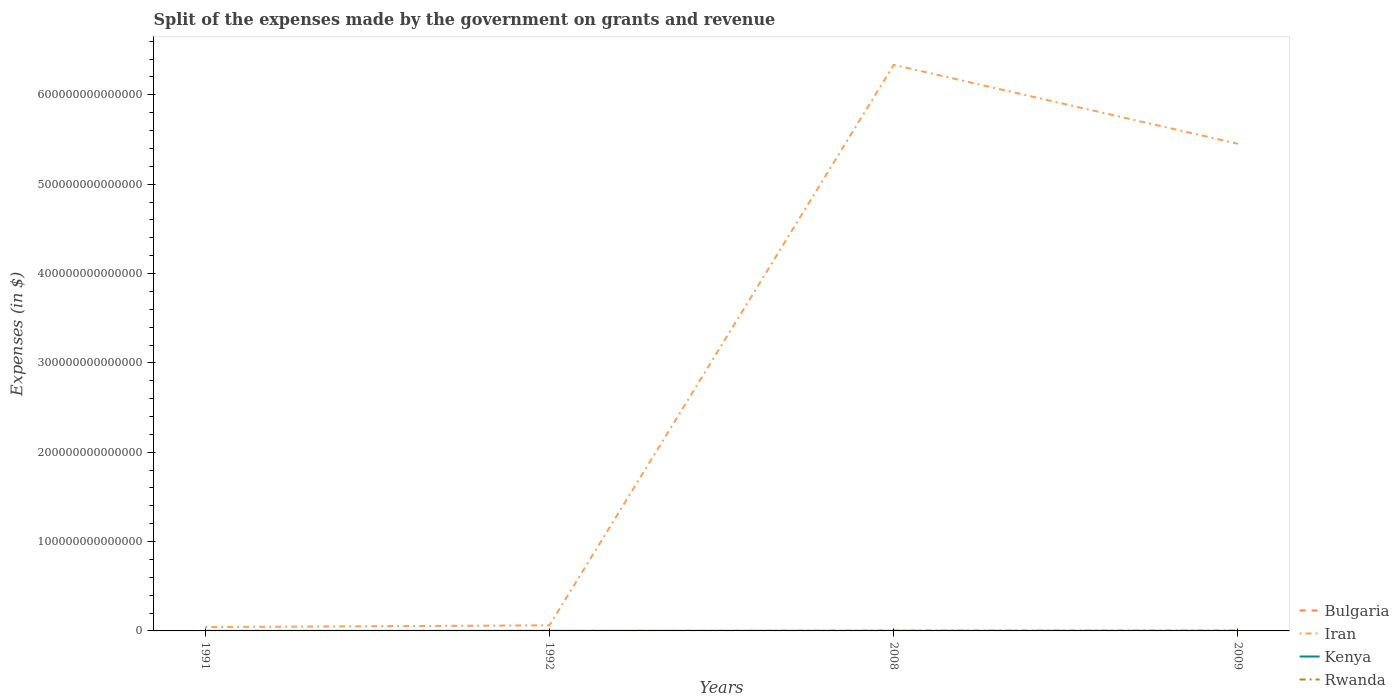Does the line corresponding to Kenya intersect with the line corresponding to Bulgaria?
Give a very brief answer. No. Is the number of lines equal to the number of legend labels?
Your response must be concise. Yes. Across all years, what is the maximum expenses made by the government on grants and revenue in Bulgaria?
Offer a very short reply. 7.79e+06. In which year was the expenses made by the government on grants and revenue in Kenya maximum?
Provide a succinct answer. 1991. What is the total expenses made by the government on grants and revenue in Bulgaria in the graph?
Provide a short and direct response. -3.49e+09. What is the difference between the highest and the second highest expenses made by the government on grants and revenue in Bulgaria?
Offer a very short reply. 3.65e+09. Is the expenses made by the government on grants and revenue in Rwanda strictly greater than the expenses made by the government on grants and revenue in Bulgaria over the years?
Provide a short and direct response. No. What is the difference between two consecutive major ticks on the Y-axis?
Make the answer very short. 1.00e+14. Are the values on the major ticks of Y-axis written in scientific E-notation?
Give a very brief answer. No. Does the graph contain any zero values?
Your answer should be compact. No. How are the legend labels stacked?
Ensure brevity in your answer.  Vertical. What is the title of the graph?
Keep it short and to the point. Split of the expenses made by the government on grants and revenue. What is the label or title of the Y-axis?
Your answer should be very brief. Expenses (in $). What is the Expenses (in $) of Bulgaria in 1991?
Your answer should be very brief. 7.79e+06. What is the Expenses (in $) of Iran in 1991?
Offer a very short reply. 4.29e+12. What is the Expenses (in $) in Kenya in 1991?
Keep it short and to the point. 7.99e+09. What is the Expenses (in $) in Rwanda in 1991?
Offer a terse response. 2.63e+09. What is the Expenses (in $) in Bulgaria in 1992?
Offer a very short reply. 1.65e+07. What is the Expenses (in $) of Iran in 1992?
Your response must be concise. 6.26e+12. What is the Expenses (in $) in Kenya in 1992?
Your response must be concise. 1.10e+1. What is the Expenses (in $) of Rwanda in 1992?
Give a very brief answer. 3.37e+09. What is the Expenses (in $) of Bulgaria in 2008?
Keep it short and to the point. 3.50e+09. What is the Expenses (in $) in Iran in 2008?
Provide a short and direct response. 6.34e+14. What is the Expenses (in $) of Kenya in 2008?
Your answer should be compact. 4.58e+1. What is the Expenses (in $) of Rwanda in 2008?
Provide a short and direct response. 2.97e+11. What is the Expenses (in $) of Bulgaria in 2009?
Offer a terse response. 3.66e+09. What is the Expenses (in $) in Iran in 2009?
Provide a short and direct response. 5.45e+14. What is the Expenses (in $) of Kenya in 2009?
Offer a very short reply. 3.98e+1. What is the Expenses (in $) of Rwanda in 2009?
Ensure brevity in your answer.  3.59e+11. Across all years, what is the maximum Expenses (in $) of Bulgaria?
Give a very brief answer. 3.66e+09. Across all years, what is the maximum Expenses (in $) in Iran?
Provide a short and direct response. 6.34e+14. Across all years, what is the maximum Expenses (in $) of Kenya?
Your response must be concise. 4.58e+1. Across all years, what is the maximum Expenses (in $) in Rwanda?
Give a very brief answer. 3.59e+11. Across all years, what is the minimum Expenses (in $) in Bulgaria?
Your answer should be very brief. 7.79e+06. Across all years, what is the minimum Expenses (in $) of Iran?
Give a very brief answer. 4.29e+12. Across all years, what is the minimum Expenses (in $) of Kenya?
Make the answer very short. 7.99e+09. Across all years, what is the minimum Expenses (in $) in Rwanda?
Give a very brief answer. 2.63e+09. What is the total Expenses (in $) in Bulgaria in the graph?
Your response must be concise. 7.19e+09. What is the total Expenses (in $) in Iran in the graph?
Your response must be concise. 1.19e+15. What is the total Expenses (in $) in Kenya in the graph?
Keep it short and to the point. 1.05e+11. What is the total Expenses (in $) in Rwanda in the graph?
Provide a short and direct response. 6.62e+11. What is the difference between the Expenses (in $) of Bulgaria in 1991 and that in 1992?
Ensure brevity in your answer.  -8.75e+06. What is the difference between the Expenses (in $) of Iran in 1991 and that in 1992?
Provide a short and direct response. -1.97e+12. What is the difference between the Expenses (in $) of Kenya in 1991 and that in 1992?
Offer a terse response. -2.97e+09. What is the difference between the Expenses (in $) of Rwanda in 1991 and that in 1992?
Your answer should be compact. -7.39e+08. What is the difference between the Expenses (in $) of Bulgaria in 1991 and that in 2008?
Ensure brevity in your answer.  -3.49e+09. What is the difference between the Expenses (in $) in Iran in 1991 and that in 2008?
Keep it short and to the point. -6.29e+14. What is the difference between the Expenses (in $) in Kenya in 1991 and that in 2008?
Offer a terse response. -3.78e+1. What is the difference between the Expenses (in $) of Rwanda in 1991 and that in 2008?
Your response must be concise. -2.94e+11. What is the difference between the Expenses (in $) in Bulgaria in 1991 and that in 2009?
Your answer should be compact. -3.65e+09. What is the difference between the Expenses (in $) in Iran in 1991 and that in 2009?
Offer a terse response. -5.41e+14. What is the difference between the Expenses (in $) in Kenya in 1991 and that in 2009?
Offer a terse response. -3.18e+1. What is the difference between the Expenses (in $) of Rwanda in 1991 and that in 2009?
Ensure brevity in your answer.  -3.57e+11. What is the difference between the Expenses (in $) in Bulgaria in 1992 and that in 2008?
Keep it short and to the point. -3.48e+09. What is the difference between the Expenses (in $) of Iran in 1992 and that in 2008?
Keep it short and to the point. -6.27e+14. What is the difference between the Expenses (in $) of Kenya in 1992 and that in 2008?
Offer a very short reply. -3.48e+1. What is the difference between the Expenses (in $) of Rwanda in 1992 and that in 2008?
Your answer should be very brief. -2.94e+11. What is the difference between the Expenses (in $) of Bulgaria in 1992 and that in 2009?
Offer a very short reply. -3.64e+09. What is the difference between the Expenses (in $) in Iran in 1992 and that in 2009?
Make the answer very short. -5.39e+14. What is the difference between the Expenses (in $) in Kenya in 1992 and that in 2009?
Ensure brevity in your answer.  -2.88e+1. What is the difference between the Expenses (in $) in Rwanda in 1992 and that in 2009?
Your answer should be compact. -3.56e+11. What is the difference between the Expenses (in $) in Bulgaria in 2008 and that in 2009?
Offer a terse response. -1.61e+08. What is the difference between the Expenses (in $) of Iran in 2008 and that in 2009?
Give a very brief answer. 8.83e+13. What is the difference between the Expenses (in $) of Kenya in 2008 and that in 2009?
Provide a short and direct response. 6.02e+09. What is the difference between the Expenses (in $) of Rwanda in 2008 and that in 2009?
Your answer should be very brief. -6.22e+1. What is the difference between the Expenses (in $) of Bulgaria in 1991 and the Expenses (in $) of Iran in 1992?
Your answer should be compact. -6.26e+12. What is the difference between the Expenses (in $) in Bulgaria in 1991 and the Expenses (in $) in Kenya in 1992?
Ensure brevity in your answer.  -1.10e+1. What is the difference between the Expenses (in $) in Bulgaria in 1991 and the Expenses (in $) in Rwanda in 1992?
Your answer should be compact. -3.36e+09. What is the difference between the Expenses (in $) in Iran in 1991 and the Expenses (in $) in Kenya in 1992?
Offer a terse response. 4.28e+12. What is the difference between the Expenses (in $) in Iran in 1991 and the Expenses (in $) in Rwanda in 1992?
Make the answer very short. 4.29e+12. What is the difference between the Expenses (in $) in Kenya in 1991 and the Expenses (in $) in Rwanda in 1992?
Your answer should be compact. 4.62e+09. What is the difference between the Expenses (in $) of Bulgaria in 1991 and the Expenses (in $) of Iran in 2008?
Offer a terse response. -6.34e+14. What is the difference between the Expenses (in $) of Bulgaria in 1991 and the Expenses (in $) of Kenya in 2008?
Your answer should be very brief. -4.58e+1. What is the difference between the Expenses (in $) in Bulgaria in 1991 and the Expenses (in $) in Rwanda in 2008?
Offer a terse response. -2.97e+11. What is the difference between the Expenses (in $) in Iran in 1991 and the Expenses (in $) in Kenya in 2008?
Provide a succinct answer. 4.24e+12. What is the difference between the Expenses (in $) of Iran in 1991 and the Expenses (in $) of Rwanda in 2008?
Provide a short and direct response. 3.99e+12. What is the difference between the Expenses (in $) of Kenya in 1991 and the Expenses (in $) of Rwanda in 2008?
Keep it short and to the point. -2.89e+11. What is the difference between the Expenses (in $) of Bulgaria in 1991 and the Expenses (in $) of Iran in 2009?
Your answer should be compact. -5.45e+14. What is the difference between the Expenses (in $) in Bulgaria in 1991 and the Expenses (in $) in Kenya in 2009?
Your response must be concise. -3.98e+1. What is the difference between the Expenses (in $) of Bulgaria in 1991 and the Expenses (in $) of Rwanda in 2009?
Ensure brevity in your answer.  -3.59e+11. What is the difference between the Expenses (in $) of Iran in 1991 and the Expenses (in $) of Kenya in 2009?
Your response must be concise. 4.25e+12. What is the difference between the Expenses (in $) in Iran in 1991 and the Expenses (in $) in Rwanda in 2009?
Offer a very short reply. 3.93e+12. What is the difference between the Expenses (in $) of Kenya in 1991 and the Expenses (in $) of Rwanda in 2009?
Offer a terse response. -3.51e+11. What is the difference between the Expenses (in $) in Bulgaria in 1992 and the Expenses (in $) in Iran in 2008?
Your answer should be very brief. -6.34e+14. What is the difference between the Expenses (in $) of Bulgaria in 1992 and the Expenses (in $) of Kenya in 2008?
Give a very brief answer. -4.58e+1. What is the difference between the Expenses (in $) of Bulgaria in 1992 and the Expenses (in $) of Rwanda in 2008?
Your answer should be very brief. -2.97e+11. What is the difference between the Expenses (in $) of Iran in 1992 and the Expenses (in $) of Kenya in 2008?
Ensure brevity in your answer.  6.22e+12. What is the difference between the Expenses (in $) of Iran in 1992 and the Expenses (in $) of Rwanda in 2008?
Offer a terse response. 5.97e+12. What is the difference between the Expenses (in $) of Kenya in 1992 and the Expenses (in $) of Rwanda in 2008?
Provide a short and direct response. -2.86e+11. What is the difference between the Expenses (in $) of Bulgaria in 1992 and the Expenses (in $) of Iran in 2009?
Provide a short and direct response. -5.45e+14. What is the difference between the Expenses (in $) in Bulgaria in 1992 and the Expenses (in $) in Kenya in 2009?
Your response must be concise. -3.98e+1. What is the difference between the Expenses (in $) of Bulgaria in 1992 and the Expenses (in $) of Rwanda in 2009?
Your answer should be compact. -3.59e+11. What is the difference between the Expenses (in $) of Iran in 1992 and the Expenses (in $) of Kenya in 2009?
Offer a very short reply. 6.22e+12. What is the difference between the Expenses (in $) in Iran in 1992 and the Expenses (in $) in Rwanda in 2009?
Ensure brevity in your answer.  5.90e+12. What is the difference between the Expenses (in $) of Kenya in 1992 and the Expenses (in $) of Rwanda in 2009?
Your answer should be compact. -3.48e+11. What is the difference between the Expenses (in $) of Bulgaria in 2008 and the Expenses (in $) of Iran in 2009?
Your answer should be compact. -5.45e+14. What is the difference between the Expenses (in $) of Bulgaria in 2008 and the Expenses (in $) of Kenya in 2009?
Your answer should be very brief. -3.63e+1. What is the difference between the Expenses (in $) in Bulgaria in 2008 and the Expenses (in $) in Rwanda in 2009?
Offer a very short reply. -3.56e+11. What is the difference between the Expenses (in $) in Iran in 2008 and the Expenses (in $) in Kenya in 2009?
Provide a succinct answer. 6.34e+14. What is the difference between the Expenses (in $) in Iran in 2008 and the Expenses (in $) in Rwanda in 2009?
Your response must be concise. 6.33e+14. What is the difference between the Expenses (in $) of Kenya in 2008 and the Expenses (in $) of Rwanda in 2009?
Your answer should be very brief. -3.13e+11. What is the average Expenses (in $) in Bulgaria per year?
Keep it short and to the point. 1.80e+09. What is the average Expenses (in $) of Iran per year?
Provide a succinct answer. 2.97e+14. What is the average Expenses (in $) of Kenya per year?
Your answer should be compact. 2.61e+1. What is the average Expenses (in $) in Rwanda per year?
Ensure brevity in your answer.  1.66e+11. In the year 1991, what is the difference between the Expenses (in $) in Bulgaria and Expenses (in $) in Iran?
Offer a very short reply. -4.29e+12. In the year 1991, what is the difference between the Expenses (in $) in Bulgaria and Expenses (in $) in Kenya?
Provide a short and direct response. -7.98e+09. In the year 1991, what is the difference between the Expenses (in $) of Bulgaria and Expenses (in $) of Rwanda?
Your answer should be very brief. -2.62e+09. In the year 1991, what is the difference between the Expenses (in $) in Iran and Expenses (in $) in Kenya?
Offer a very short reply. 4.28e+12. In the year 1991, what is the difference between the Expenses (in $) of Iran and Expenses (in $) of Rwanda?
Your response must be concise. 4.29e+12. In the year 1991, what is the difference between the Expenses (in $) of Kenya and Expenses (in $) of Rwanda?
Keep it short and to the point. 5.36e+09. In the year 1992, what is the difference between the Expenses (in $) in Bulgaria and Expenses (in $) in Iran?
Your answer should be compact. -6.26e+12. In the year 1992, what is the difference between the Expenses (in $) in Bulgaria and Expenses (in $) in Kenya?
Offer a terse response. -1.09e+1. In the year 1992, what is the difference between the Expenses (in $) of Bulgaria and Expenses (in $) of Rwanda?
Provide a short and direct response. -3.35e+09. In the year 1992, what is the difference between the Expenses (in $) in Iran and Expenses (in $) in Kenya?
Make the answer very short. 6.25e+12. In the year 1992, what is the difference between the Expenses (in $) of Iran and Expenses (in $) of Rwanda?
Your answer should be very brief. 6.26e+12. In the year 1992, what is the difference between the Expenses (in $) of Kenya and Expenses (in $) of Rwanda?
Your answer should be very brief. 7.59e+09. In the year 2008, what is the difference between the Expenses (in $) in Bulgaria and Expenses (in $) in Iran?
Ensure brevity in your answer.  -6.34e+14. In the year 2008, what is the difference between the Expenses (in $) in Bulgaria and Expenses (in $) in Kenya?
Ensure brevity in your answer.  -4.23e+1. In the year 2008, what is the difference between the Expenses (in $) in Bulgaria and Expenses (in $) in Rwanda?
Keep it short and to the point. -2.93e+11. In the year 2008, what is the difference between the Expenses (in $) in Iran and Expenses (in $) in Kenya?
Your answer should be compact. 6.34e+14. In the year 2008, what is the difference between the Expenses (in $) of Iran and Expenses (in $) of Rwanda?
Keep it short and to the point. 6.33e+14. In the year 2008, what is the difference between the Expenses (in $) in Kenya and Expenses (in $) in Rwanda?
Ensure brevity in your answer.  -2.51e+11. In the year 2009, what is the difference between the Expenses (in $) of Bulgaria and Expenses (in $) of Iran?
Offer a terse response. -5.45e+14. In the year 2009, what is the difference between the Expenses (in $) in Bulgaria and Expenses (in $) in Kenya?
Offer a terse response. -3.61e+1. In the year 2009, what is the difference between the Expenses (in $) of Bulgaria and Expenses (in $) of Rwanda?
Offer a terse response. -3.55e+11. In the year 2009, what is the difference between the Expenses (in $) of Iran and Expenses (in $) of Kenya?
Your answer should be compact. 5.45e+14. In the year 2009, what is the difference between the Expenses (in $) of Iran and Expenses (in $) of Rwanda?
Your answer should be compact. 5.45e+14. In the year 2009, what is the difference between the Expenses (in $) of Kenya and Expenses (in $) of Rwanda?
Your response must be concise. -3.19e+11. What is the ratio of the Expenses (in $) of Bulgaria in 1991 to that in 1992?
Ensure brevity in your answer.  0.47. What is the ratio of the Expenses (in $) in Iran in 1991 to that in 1992?
Your response must be concise. 0.68. What is the ratio of the Expenses (in $) in Kenya in 1991 to that in 1992?
Provide a short and direct response. 0.73. What is the ratio of the Expenses (in $) in Rwanda in 1991 to that in 1992?
Your response must be concise. 0.78. What is the ratio of the Expenses (in $) in Bulgaria in 1991 to that in 2008?
Keep it short and to the point. 0. What is the ratio of the Expenses (in $) of Iran in 1991 to that in 2008?
Ensure brevity in your answer.  0.01. What is the ratio of the Expenses (in $) in Kenya in 1991 to that in 2008?
Ensure brevity in your answer.  0.17. What is the ratio of the Expenses (in $) of Rwanda in 1991 to that in 2008?
Your response must be concise. 0.01. What is the ratio of the Expenses (in $) in Bulgaria in 1991 to that in 2009?
Provide a short and direct response. 0. What is the ratio of the Expenses (in $) in Iran in 1991 to that in 2009?
Your response must be concise. 0.01. What is the ratio of the Expenses (in $) of Kenya in 1991 to that in 2009?
Ensure brevity in your answer.  0.2. What is the ratio of the Expenses (in $) in Rwanda in 1991 to that in 2009?
Give a very brief answer. 0.01. What is the ratio of the Expenses (in $) in Bulgaria in 1992 to that in 2008?
Your response must be concise. 0. What is the ratio of the Expenses (in $) of Iran in 1992 to that in 2008?
Your answer should be compact. 0.01. What is the ratio of the Expenses (in $) in Kenya in 1992 to that in 2008?
Provide a short and direct response. 0.24. What is the ratio of the Expenses (in $) in Rwanda in 1992 to that in 2008?
Offer a very short reply. 0.01. What is the ratio of the Expenses (in $) of Bulgaria in 1992 to that in 2009?
Offer a very short reply. 0. What is the ratio of the Expenses (in $) of Iran in 1992 to that in 2009?
Your answer should be very brief. 0.01. What is the ratio of the Expenses (in $) of Kenya in 1992 to that in 2009?
Offer a very short reply. 0.28. What is the ratio of the Expenses (in $) in Rwanda in 1992 to that in 2009?
Provide a succinct answer. 0.01. What is the ratio of the Expenses (in $) in Bulgaria in 2008 to that in 2009?
Provide a short and direct response. 0.96. What is the ratio of the Expenses (in $) in Iran in 2008 to that in 2009?
Give a very brief answer. 1.16. What is the ratio of the Expenses (in $) of Kenya in 2008 to that in 2009?
Make the answer very short. 1.15. What is the ratio of the Expenses (in $) in Rwanda in 2008 to that in 2009?
Your answer should be compact. 0.83. What is the difference between the highest and the second highest Expenses (in $) of Bulgaria?
Provide a succinct answer. 1.61e+08. What is the difference between the highest and the second highest Expenses (in $) of Iran?
Make the answer very short. 8.83e+13. What is the difference between the highest and the second highest Expenses (in $) in Kenya?
Keep it short and to the point. 6.02e+09. What is the difference between the highest and the second highest Expenses (in $) of Rwanda?
Provide a succinct answer. 6.22e+1. What is the difference between the highest and the lowest Expenses (in $) in Bulgaria?
Ensure brevity in your answer.  3.65e+09. What is the difference between the highest and the lowest Expenses (in $) of Iran?
Ensure brevity in your answer.  6.29e+14. What is the difference between the highest and the lowest Expenses (in $) in Kenya?
Keep it short and to the point. 3.78e+1. What is the difference between the highest and the lowest Expenses (in $) in Rwanda?
Give a very brief answer. 3.57e+11. 